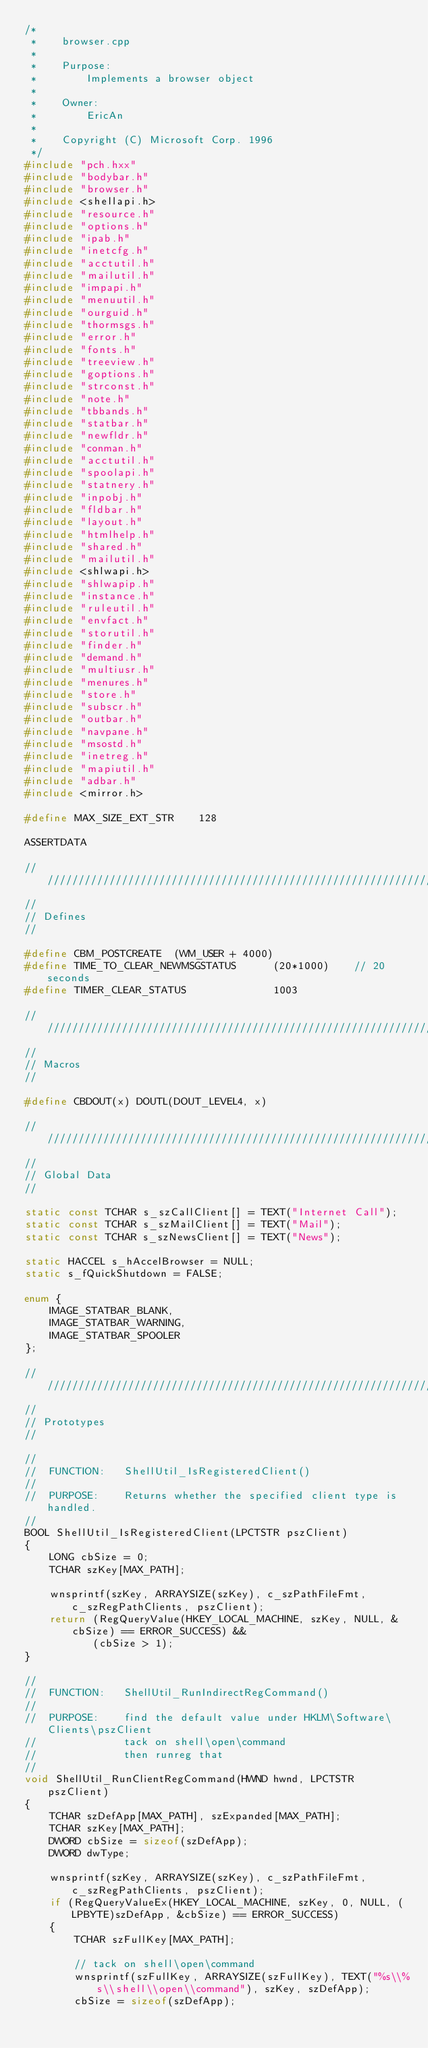<code> <loc_0><loc_0><loc_500><loc_500><_C++_>/*
 *    browser.cpp                                                  
 *    
 *    Purpose:                     
 *        Implements a browser object
 *    
 *    Owner:
 *        EricAn
 *    
 *    Copyright (C) Microsoft Corp. 1996
 */
#include "pch.hxx"
#include "bodybar.h"
#include "browser.h"
#include <shellapi.h>
#include "resource.h"
#include "options.h"
#include "ipab.h"
#include "inetcfg.h"
#include "acctutil.h"
#include "mailutil.h"
#include "impapi.h"
#include "menuutil.h"
#include "ourguid.h"
#include "thormsgs.h"
#include "error.h"
#include "fonts.h"
#include "treeview.h"
#include "goptions.h"
#include "strconst.h"
#include "note.h"
#include "tbbands.h"
#include "statbar.h"
#include "newfldr.h"
#include "conman.h"
#include "acctutil.h"
#include "spoolapi.h"
#include "statnery.h"
#include "inpobj.h"
#include "fldbar.h"
#include "layout.h"
#include "htmlhelp.h"
#include "shared.h"
#include "mailutil.h"
#include <shlwapi.h>
#include "shlwapip.h" 
#include "instance.h"
#include "ruleutil.h"
#include "envfact.h"
#include "storutil.h"
#include "finder.h"
#include "demand.h"
#include "multiusr.h"
#include "menures.h"
#include "store.h"
#include "subscr.h"
#include "outbar.h"
#include "navpane.h"
#include "msostd.h"
#include "inetreg.h"
#include "mapiutil.h"
#include "adbar.h"
#include <mirror.h>

#define MAX_SIZE_EXT_STR    128

ASSERTDATA

/////////////////////////////////////////////////////////////////////////////
// 
// Defines
//

#define CBM_POSTCREATE  (WM_USER + 4000)
#define TIME_TO_CLEAR_NEWMSGSTATUS      (20*1000)    // 20 seconds
#define TIMER_CLEAR_STATUS              1003

/////////////////////////////////////////////////////////////////////////////
// 
// Macros
//

#define CBDOUT(x) DOUTL(DOUT_LEVEL4, x)

/////////////////////////////////////////////////////////////////////////////
//
// Global Data
//

static const TCHAR s_szCallClient[] = TEXT("Internet Call");
static const TCHAR s_szMailClient[] = TEXT("Mail");
static const TCHAR s_szNewsClient[] = TEXT("News");

static HACCEL s_hAccelBrowser = NULL;
static s_fQuickShutdown = FALSE;

enum {
    IMAGE_STATBAR_BLANK,
    IMAGE_STATBAR_WARNING,
    IMAGE_STATBAR_SPOOLER
};

/////////////////////////////////////////////////////////////////////////////
// 
// Prototypes
//

//
//  FUNCTION:   ShellUtil_IsRegisteredClient()
//
//  PURPOSE:    Returns whether the specified client type is handled.
//
BOOL ShellUtil_IsRegisteredClient(LPCTSTR pszClient)
{
    LONG cbSize = 0;
    TCHAR szKey[MAX_PATH];
    
    wnsprintf(szKey, ARRAYSIZE(szKey), c_szPathFileFmt, c_szRegPathClients, pszClient);
    return (RegQueryValue(HKEY_LOCAL_MACHINE, szKey, NULL, &cbSize) == ERROR_SUCCESS) && 
           (cbSize > 1);
}

//
//  FUNCTION:   ShellUtil_RunIndirectRegCommand()
//
//  PURPOSE:    find the default value under HKLM\Software\Clients\pszClient
//              tack on shell\open\command
//              then runreg that
//
void ShellUtil_RunClientRegCommand(HWND hwnd, LPCTSTR pszClient)
{
    TCHAR szDefApp[MAX_PATH], szExpanded[MAX_PATH];
    TCHAR szKey[MAX_PATH];
    DWORD cbSize = sizeof(szDefApp);
    DWORD dwType;
    
    wnsprintf(szKey, ARRAYSIZE(szKey), c_szPathFileFmt, c_szRegPathClients, pszClient);
    if (RegQueryValueEx(HKEY_LOCAL_MACHINE, szKey, 0, NULL, (LPBYTE)szDefApp, &cbSize) == ERROR_SUCCESS) 
    {        
        TCHAR szFullKey[MAX_PATH];
        
        // tack on shell\open\command
        wnsprintf(szFullKey, ARRAYSIZE(szFullKey), TEXT("%s\\%s\\shell\\open\\command"), szKey, szDefApp);
        cbSize = sizeof(szDefApp);</code> 